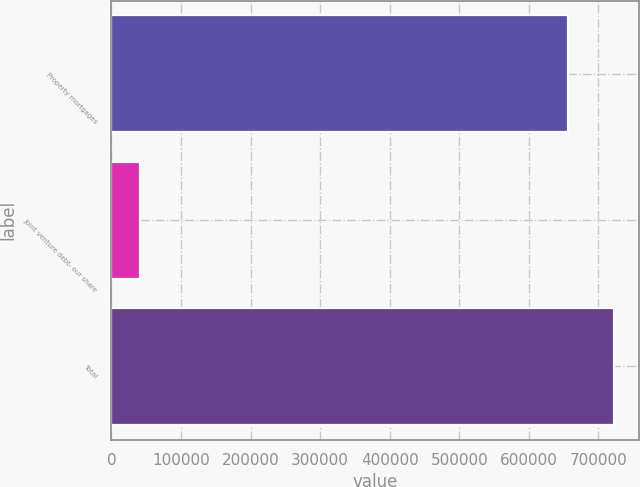Convert chart. <chart><loc_0><loc_0><loc_500><loc_500><bar_chart><fcel>Property mortgages<fcel>Joint venture debt- our share<fcel>Total<nl><fcel>656863<fcel>41415<fcel>722549<nl></chart> 